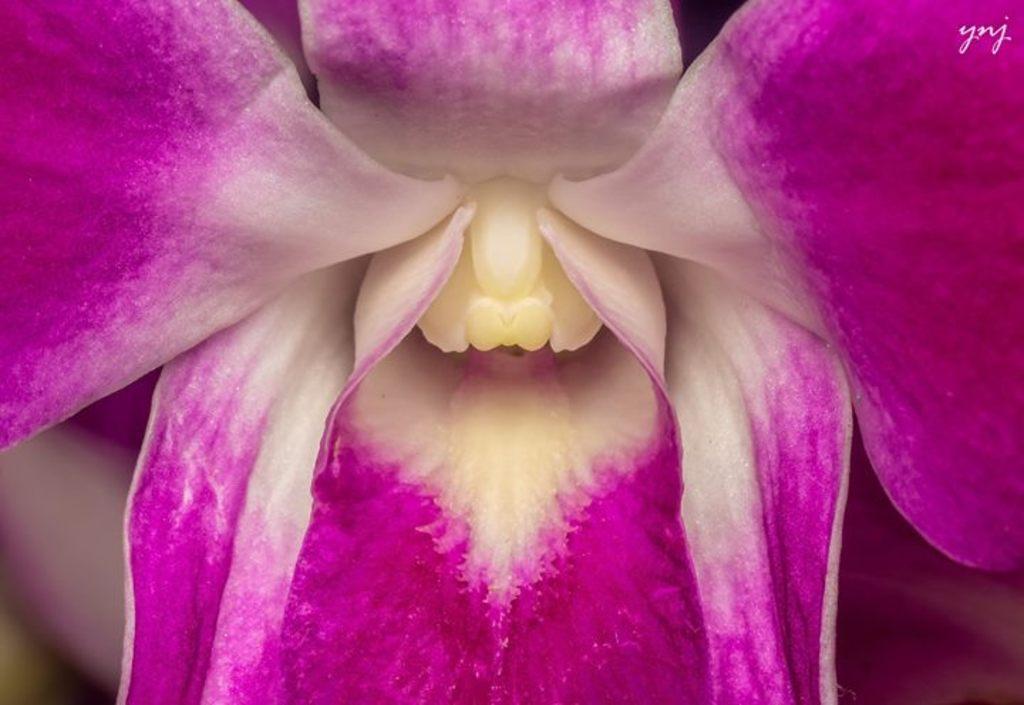In one or two sentences, can you explain what this image depicts? In the center of the image we can see one flower, which is in pink, white and cream color. On the top right side of the image, we can see some text. 